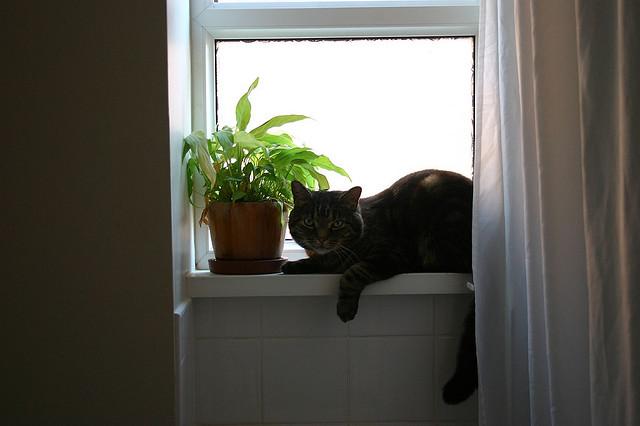Where is the cat laying?
Keep it brief. Window sill. What color are the flowers?
Be succinct. Green. What is the cat looking at?
Short answer required. Camera. What room is this?
Be succinct. Bathroom. What color are the cat's paws?
Keep it brief. Black. What is next to the cat?
Short answer required. Plant. 